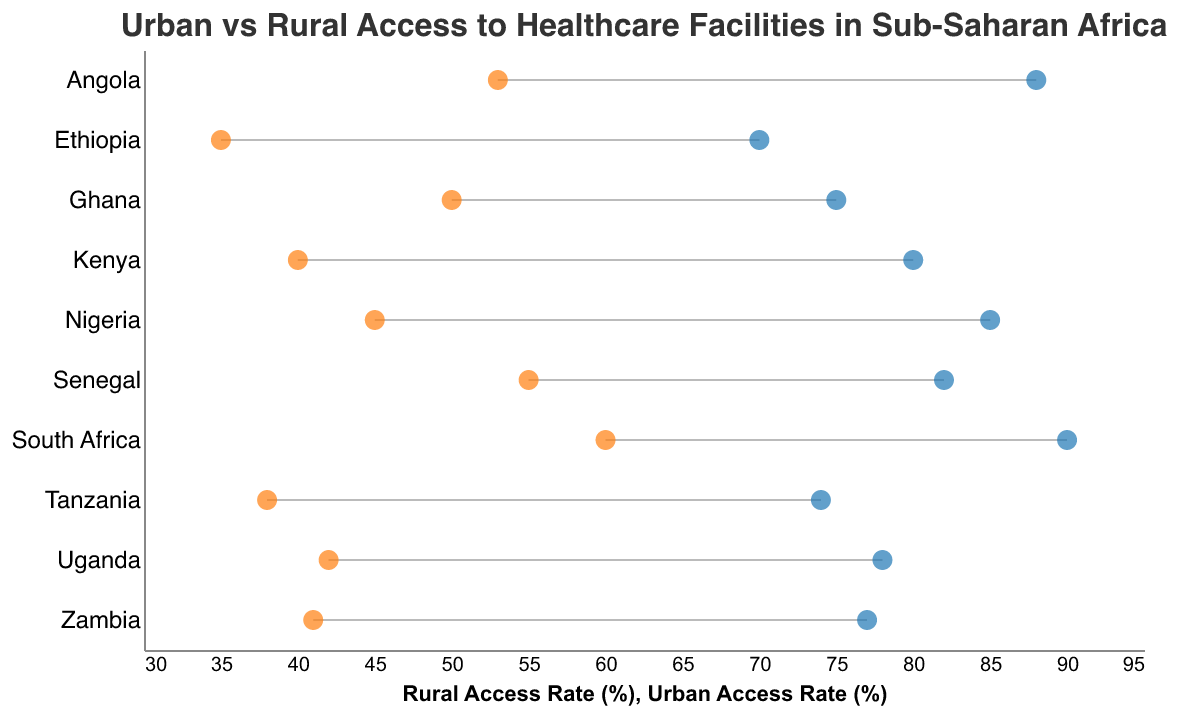What is the title of the figure? The title is displayed at the top of the figure as a heading.
Answer: Urban vs Rural Access to Healthcare Facilities in Sub-Saharan Africa Which country has the highest Urban Access Rate (%) to healthcare facilities? By looking at the urban access rates plotted as blue dots, the highest point corresponds to South Africa, which has an access rate of 90%.
Answer: South Africa What is the difference in Urban Access Rate (%) and Rural Access Rate (%) for Nigeria? Urban Access Rate for Nigeria is 85%, and Rural Access Rate is 45%. The difference is calculated as 85% - 45% = 40%.
Answer: 40% Which country has the smallest gap between Urban and Rural Access Rates? By comparing the lengths of the bars (the difference between urban and rural access rates), Ghana has the smallest gap, with urban access at 75% and rural at 50%, giving a difference of 25%.
Answer: Ghana How many countries have a Rural Access Rate (%) that is less than 40%? By counting the orange points on the horizontal axis below 40%, we find Kenya (40%), Ethiopia (35%), and Tanzania (38%). There are 3 countries in total.
Answer: 3 Between Nigeria and Angola, which country has a lower Rural Access Rate (%)? By comparing the orange dots corresponding to Nigeria and Angola, Nigeria has a Rural Access Rate of 45%, while Angola has 53%. Nigeria has the lower rate.
Answer: Nigeria What is the average Rural Access Rate (%) for the listed countries? Sum of rural access rates: 45 + 40 + 60 + 35 + 50 + 42 + 38 + 55 + 41 + 53 = 459. Average is 459 / 10 = 45.9%.
Answer: 45.9% In Tanzania, by how many percentage points does the Urban Access Rate exceed the Rural Access Rate? For Tanzania, the Urban Access Rate is 74% and the Rural Access Rate is 38%. The difference is 74% - 38% = 36 percentage points.
Answer: 36 Which country has the second highest Rural Access Rate (%)? The second highest orange dot corresponds to Angola with a rural access rate of 53%, after South Africa at 60%.
Answer: Angola Do any countries have an Urban Access Rate (%) and Rural Access Rate (%) that are both above 80%? By checking the points, no country has both urban and rural access rates above 80%. The highest rural rate is 60% (South Africa), and no urban access rate above 80% has a corresponding rural rate above 80%.
Answer: No 